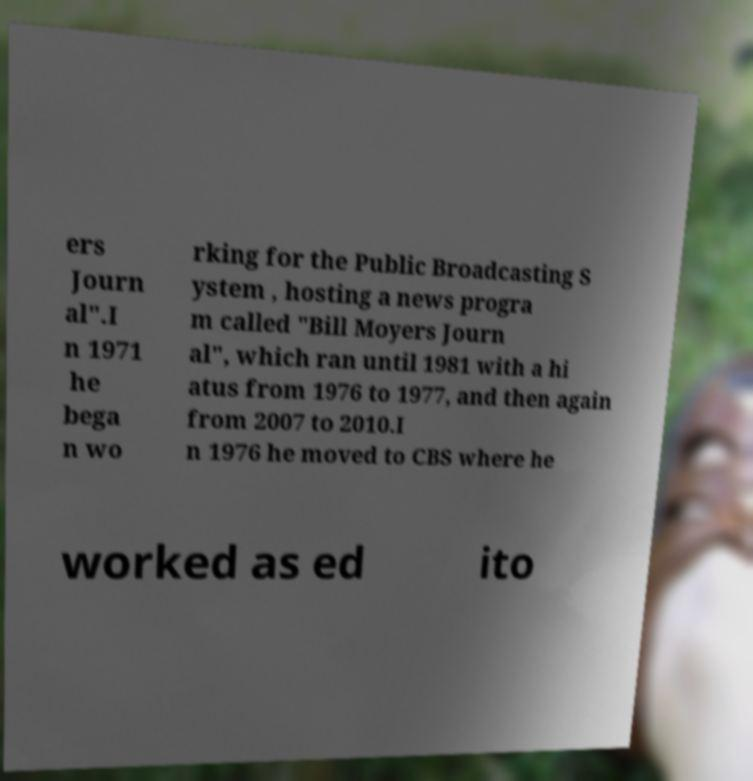I need the written content from this picture converted into text. Can you do that? ers Journ al".I n 1971 he bega n wo rking for the Public Broadcasting S ystem , hosting a news progra m called "Bill Moyers Journ al", which ran until 1981 with a hi atus from 1976 to 1977, and then again from 2007 to 2010.I n 1976 he moved to CBS where he worked as ed ito 